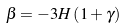Convert formula to latex. <formula><loc_0><loc_0><loc_500><loc_500>\beta = - 3 H \left ( 1 + \gamma \right )</formula> 